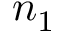Convert formula to latex. <formula><loc_0><loc_0><loc_500><loc_500>n _ { 1 }</formula> 